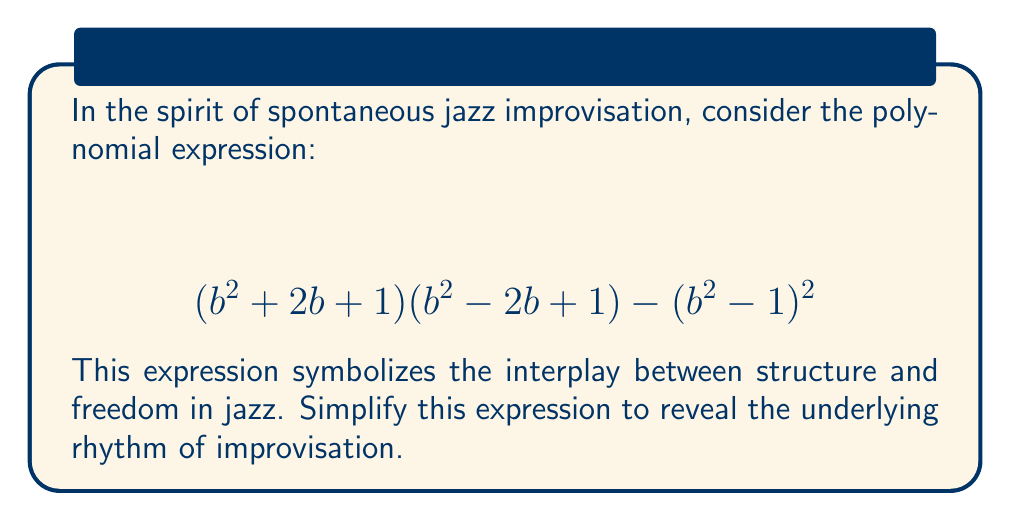Could you help me with this problem? Let's approach this step-by-step, like the layered rhythms in a jazz piece:

1) First, let's expand $(b^2 + 2b + 1)(b^2 - 2b + 1)$:
   $$(b^2 + 2b + 1)(b^2 - 2b + 1) = b^4 - 2b^3 + b^2 + 2b^3 - 4b^2 + 2b + b^2 - 2b + 1$$
   $$= b^4 - 2b^2 + 1$$

2) Now, let's expand $(b^2 - 1)^2$:
   $$(b^2 - 1)^2 = b^4 - 2b^2 + 1$$

3) Our expression now looks like this:
   $$(b^4 - 2b^2 + 1) - (b^4 - 2b^2 + 1)$$

4) Subtracting these identical terms:
   $$b^4 - 2b^2 + 1 - b^4 + 2b^2 - 1 = 0$$

Just as in jazz improvisation, where complex patterns often resolve into simple, elegant phrases, our complex polynomial has simplified to zero, symbolizing the perfect balance and resolution in a jazz performance.
Answer: $$0$$ 